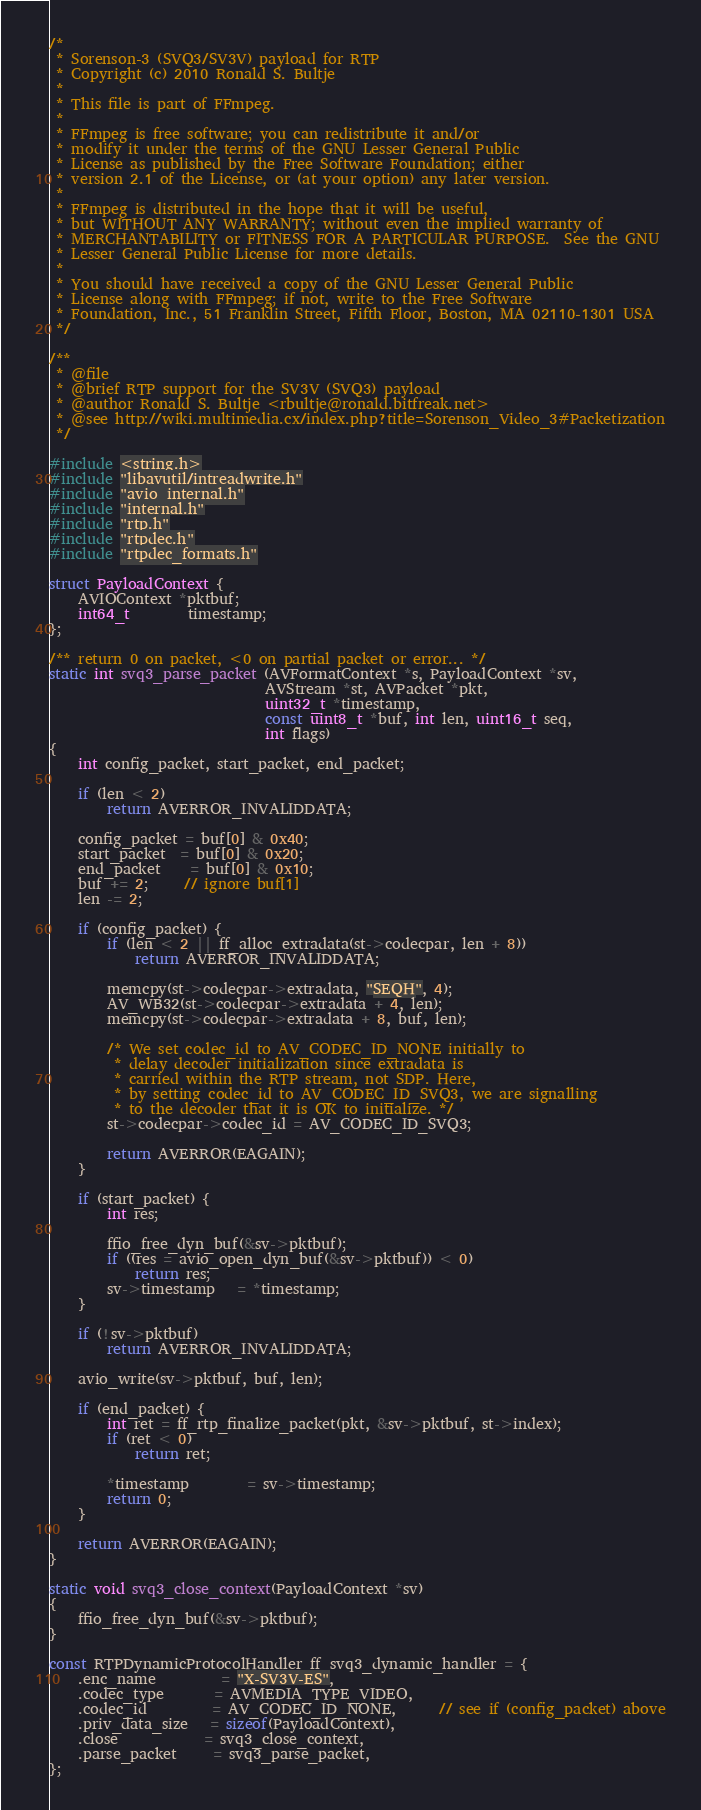Convert code to text. <code><loc_0><loc_0><loc_500><loc_500><_C_>/*
 * Sorenson-3 (SVQ3/SV3V) payload for RTP
 * Copyright (c) 2010 Ronald S. Bultje
 *
 * This file is part of FFmpeg.
 *
 * FFmpeg is free software; you can redistribute it and/or
 * modify it under the terms of the GNU Lesser General Public
 * License as published by the Free Software Foundation; either
 * version 2.1 of the License, or (at your option) any later version.
 *
 * FFmpeg is distributed in the hope that it will be useful,
 * but WITHOUT ANY WARRANTY; without even the implied warranty of
 * MERCHANTABILITY or FITNESS FOR A PARTICULAR PURPOSE.  See the GNU
 * Lesser General Public License for more details.
 *
 * You should have received a copy of the GNU Lesser General Public
 * License along with FFmpeg; if not, write to the Free Software
 * Foundation, Inc., 51 Franklin Street, Fifth Floor, Boston, MA 02110-1301 USA
 */

/**
 * @file
 * @brief RTP support for the SV3V (SVQ3) payload
 * @author Ronald S. Bultje <rbultje@ronald.bitfreak.net>
 * @see http://wiki.multimedia.cx/index.php?title=Sorenson_Video_3#Packetization
 */

#include <string.h>
#include "libavutil/intreadwrite.h"
#include "avio_internal.h"
#include "internal.h"
#include "rtp.h"
#include "rtpdec.h"
#include "rtpdec_formats.h"

struct PayloadContext {
    AVIOContext *pktbuf;
    int64_t        timestamp;
};

/** return 0 on packet, <0 on partial packet or error... */
static int svq3_parse_packet (AVFormatContext *s, PayloadContext *sv,
                              AVStream *st, AVPacket *pkt,
                              uint32_t *timestamp,
                              const uint8_t *buf, int len, uint16_t seq,
                              int flags)
{
    int config_packet, start_packet, end_packet;

    if (len < 2)
        return AVERROR_INVALIDDATA;

    config_packet = buf[0] & 0x40;
    start_packet  = buf[0] & 0x20;
    end_packet    = buf[0] & 0x10;
    buf += 2;     // ignore buf[1]
    len -= 2;

    if (config_packet) {
        if (len < 2 || ff_alloc_extradata(st->codecpar, len + 8))
            return AVERROR_INVALIDDATA;

        memcpy(st->codecpar->extradata, "SEQH", 4);
        AV_WB32(st->codecpar->extradata + 4, len);
        memcpy(st->codecpar->extradata + 8, buf, len);

        /* We set codec_id to AV_CODEC_ID_NONE initially to
         * delay decoder initialization since extradata is
         * carried within the RTP stream, not SDP. Here,
         * by setting codec_id to AV_CODEC_ID_SVQ3, we are signalling
         * to the decoder that it is OK to initialize. */
        st->codecpar->codec_id = AV_CODEC_ID_SVQ3;

        return AVERROR(EAGAIN);
    }

    if (start_packet) {
        int res;

        ffio_free_dyn_buf(&sv->pktbuf);
        if ((res = avio_open_dyn_buf(&sv->pktbuf)) < 0)
            return res;
        sv->timestamp   = *timestamp;
    }

    if (!sv->pktbuf)
        return AVERROR_INVALIDDATA;

    avio_write(sv->pktbuf, buf, len);

    if (end_packet) {
        int ret = ff_rtp_finalize_packet(pkt, &sv->pktbuf, st->index);
        if (ret < 0)
            return ret;

        *timestamp        = sv->timestamp;
        return 0;
    }

    return AVERROR(EAGAIN);
}

static void svq3_close_context(PayloadContext *sv)
{
    ffio_free_dyn_buf(&sv->pktbuf);
}

const RTPDynamicProtocolHandler ff_svq3_dynamic_handler = {
    .enc_name         = "X-SV3V-ES",
    .codec_type       = AVMEDIA_TYPE_VIDEO,
    .codec_id         = AV_CODEC_ID_NONE,      // see if (config_packet) above
    .priv_data_size   = sizeof(PayloadContext),
    .close            = svq3_close_context,
    .parse_packet     = svq3_parse_packet,
};
</code> 